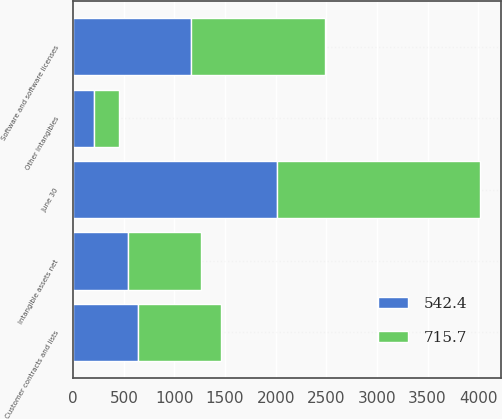Convert chart. <chart><loc_0><loc_0><loc_500><loc_500><stacked_bar_chart><ecel><fcel>June 30<fcel>Software and software licenses<fcel>Customer contracts and lists<fcel>Other intangibles<fcel>Intangible assets net<nl><fcel>715.7<fcel>2011<fcel>1322.4<fcel>821<fcel>238.3<fcel>715.7<nl><fcel>542.4<fcel>2010<fcel>1160<fcel>640.3<fcel>209.5<fcel>542.4<nl></chart> 